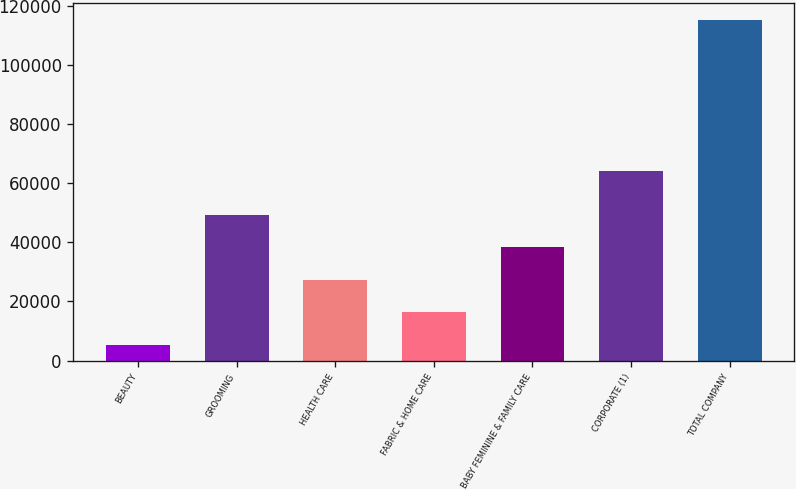Convert chart. <chart><loc_0><loc_0><loc_500><loc_500><bar_chart><fcel>BEAUTY<fcel>GROOMING<fcel>HEALTH CARE<fcel>FABRIC & HOME CARE<fcel>BABY FEMININE & FAMILY CARE<fcel>CORPORATE (1)<fcel>TOTAL COMPANY<nl><fcel>5362<fcel>49255.2<fcel>27308.6<fcel>16335.3<fcel>38281.9<fcel>64252<fcel>115095<nl></chart> 